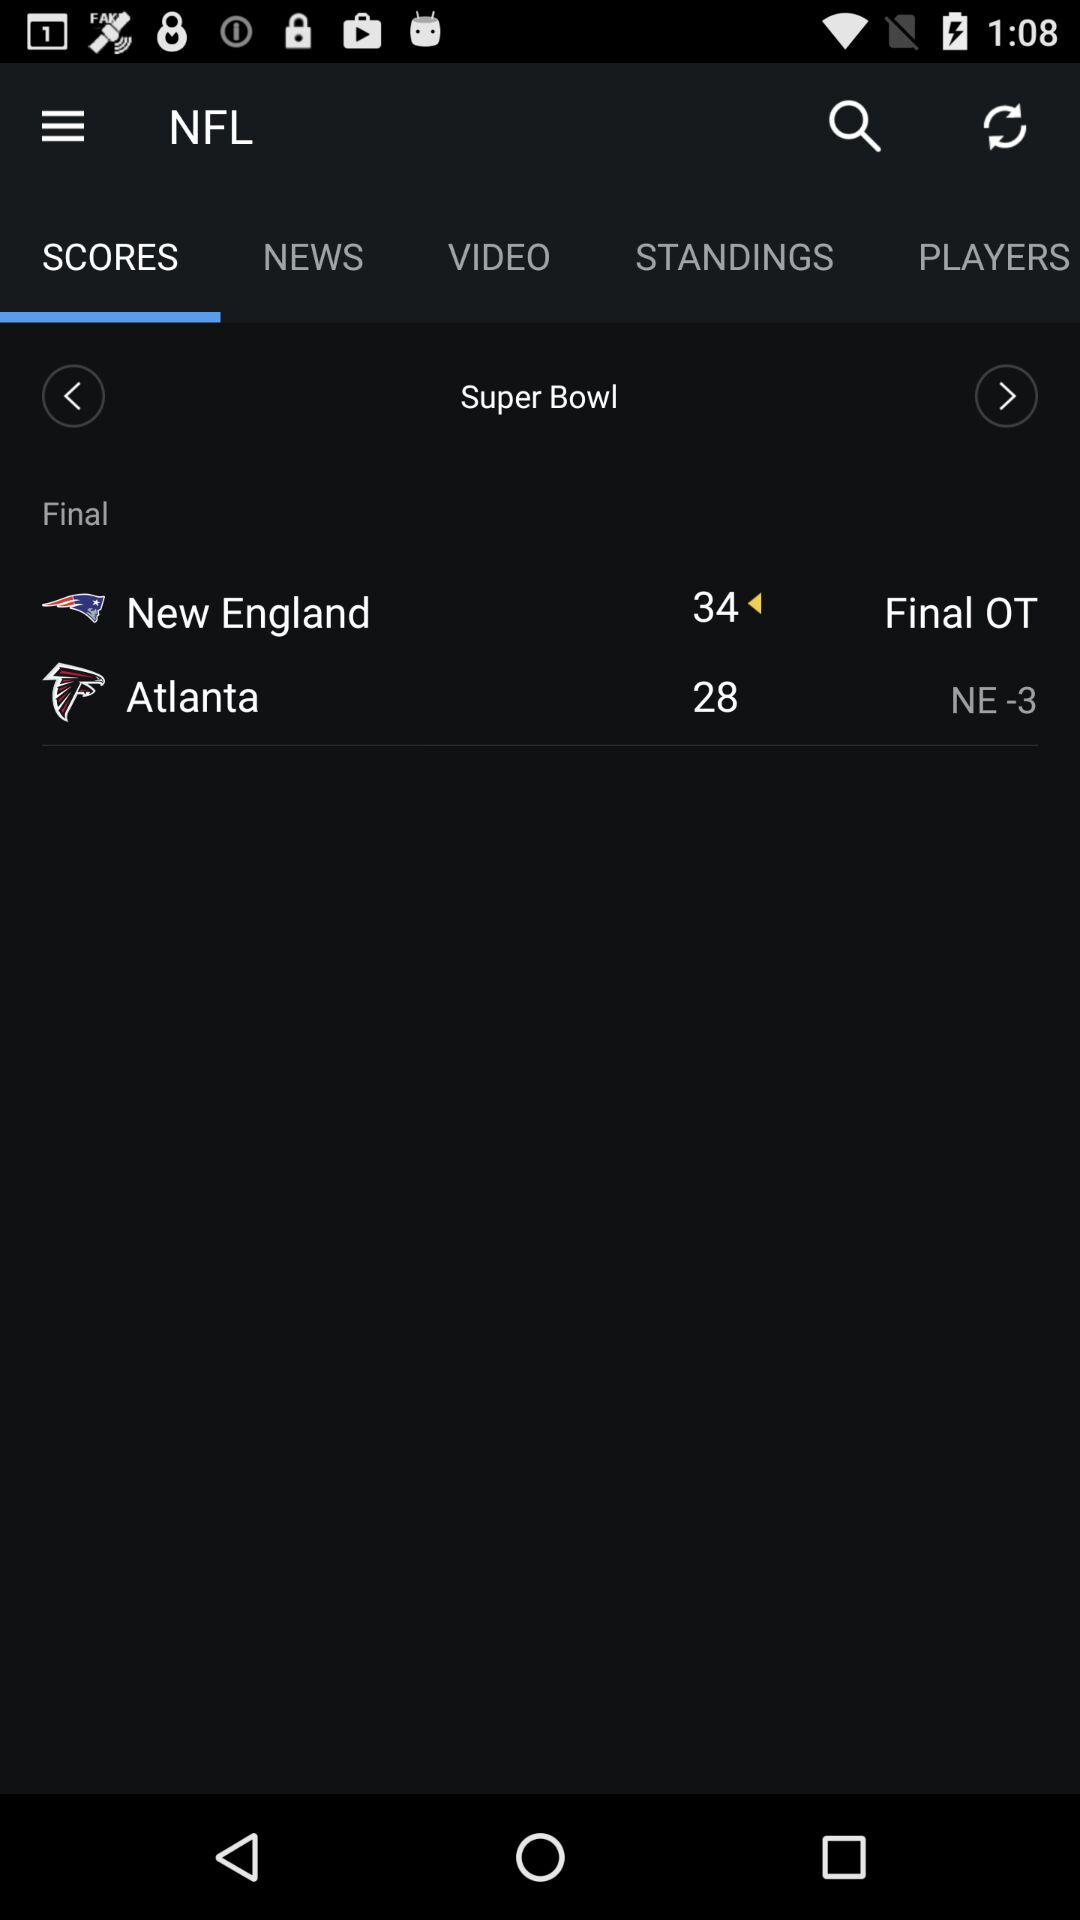How many more points did New England score than Atlanta?
Answer the question using a single word or phrase. 6 